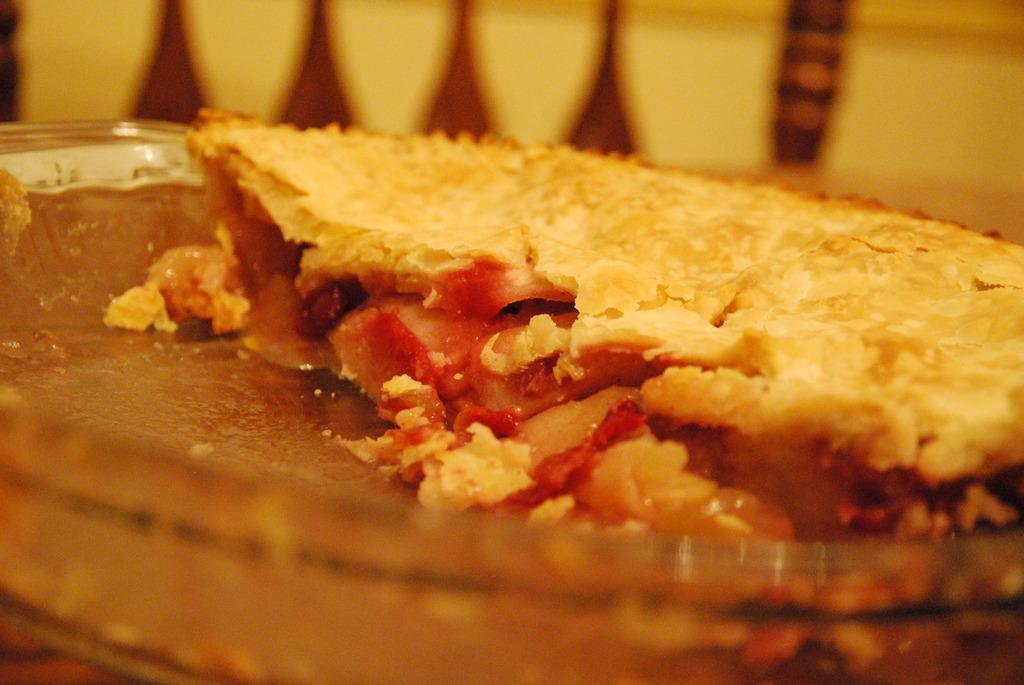What is the main subject of the image? There is a food item on a glass plate in the image. Can you describe the background of the image? The background of the image has yellow and brown colors. How many elbows can be seen in the image? There are no elbows visible in the image. What type of vegetable is being moved around in the image? There is no vegetable, such as cabbage, present in the image. 